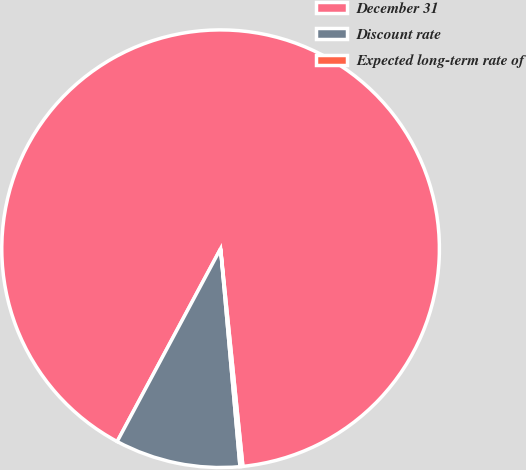Convert chart to OTSL. <chart><loc_0><loc_0><loc_500><loc_500><pie_chart><fcel>December 31<fcel>Discount rate<fcel>Expected long-term rate of<nl><fcel>90.54%<fcel>9.25%<fcel>0.21%<nl></chart> 